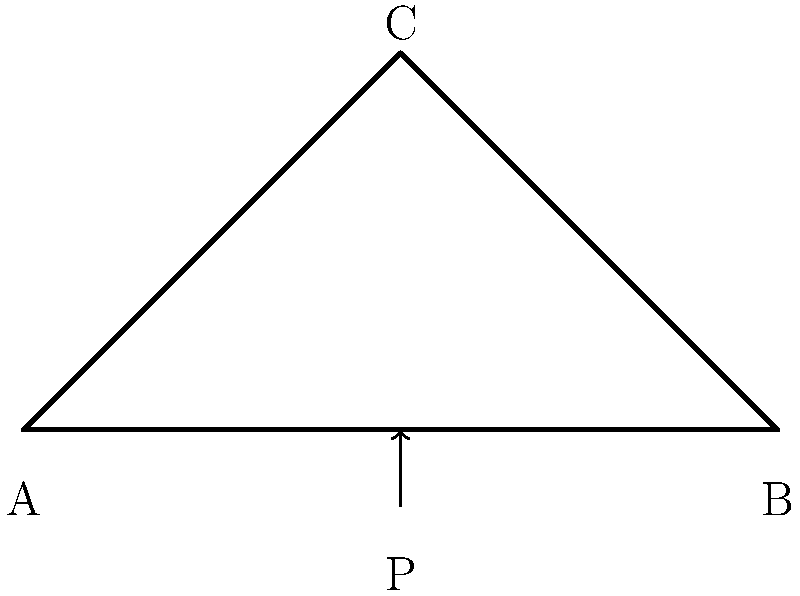Given the structural diagram of a simple truss bridge, calculate the maximum load $P$ that can be applied at the center point C if the tensile strength of each member is 100 kN and the bridge span $L$ is 10 meters. Assume the bridge members AC and BC are identical and form a 45-degree angle with the horizontal. To solve this problem, we'll follow these steps:

1) First, we need to understand that in a symmetrical truss bridge, the load P at the center is equally distributed between the two diagonal members AC and BC.

2) The force in each diagonal member (AC and BC) will be tensile and at an angle of 45 degrees to the horizontal.

3) We can use trigonometry to resolve the forces:
   Let F be the force in each diagonal member.
   Vertical component of F = F * sin(45°) = F * (1/√2)
   
4) The total vertical force must equal the applied load P:
   P = 2 * F * (1/√2)

5) We're given that the tensile strength of each member is 100 kN. This is the maximum force each member can withstand. So, F = 100 kN.

6) Substituting this into our equation:
   P = 2 * 100 * (1/√2) = 200 * (1/√2) = 200/√2 ≈ 141.4 kN

7) To verify, we can check if this load produces exactly 100 kN in each diagonal member:
   F = (P/2) * √2 = (141.4/2) * √2 ≈ 100 kN

Therefore, the maximum load P that can be applied at the center point C is approximately 141.4 kN.
Answer: 141.4 kN 